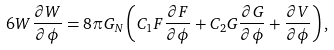<formula> <loc_0><loc_0><loc_500><loc_500>6 W \frac { \partial W } { \partial \phi } = 8 \pi G _ { N } \left ( C _ { 1 } F \frac { \partial F } { \partial \phi } + C _ { 2 } G \frac { \partial G } { \partial \phi } + \frac { \partial V } { \partial \phi } \right ) ,</formula> 